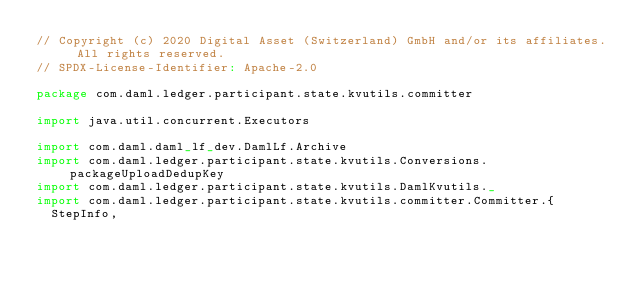<code> <loc_0><loc_0><loc_500><loc_500><_Scala_>// Copyright (c) 2020 Digital Asset (Switzerland) GmbH and/or its affiliates. All rights reserved.
// SPDX-License-Identifier: Apache-2.0

package com.daml.ledger.participant.state.kvutils.committer

import java.util.concurrent.Executors

import com.daml.daml_lf_dev.DamlLf.Archive
import com.daml.ledger.participant.state.kvutils.Conversions.packageUploadDedupKey
import com.daml.ledger.participant.state.kvutils.DamlKvutils._
import com.daml.ledger.participant.state.kvutils.committer.Committer.{
  StepInfo,</code> 